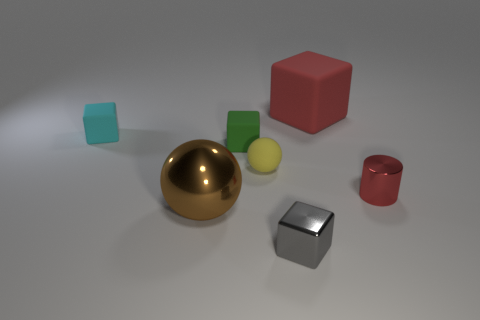Does the large rubber cube have the same color as the metal cylinder?
Offer a terse response. Yes. There is another rubber thing that is the same shape as the brown object; what color is it?
Keep it short and to the point. Yellow. How many tiny metallic objects have the same color as the large matte block?
Offer a very short reply. 1. Are there any other things that have the same shape as the tiny red metallic object?
Your response must be concise. No. There is a rubber cube behind the small block behind the small green matte block; is there a tiny red metallic object that is right of it?
Offer a terse response. Yes. How many small green objects have the same material as the small yellow ball?
Offer a terse response. 1. There is a rubber cube that is behind the cyan matte block; does it have the same size as the ball in front of the tiny cylinder?
Your response must be concise. Yes. What color is the large block behind the small cube that is in front of the ball left of the yellow thing?
Offer a very short reply. Red. Is there a cyan thing that has the same shape as the tiny gray thing?
Make the answer very short. Yes. Is the number of red matte cubes left of the cyan cube the same as the number of matte cubes to the right of the tiny yellow rubber ball?
Keep it short and to the point. No. 